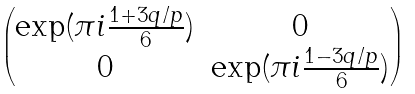Convert formula to latex. <formula><loc_0><loc_0><loc_500><loc_500>\begin{pmatrix} \exp ( \pi i \frac { 1 + 3 q / p } { 6 } ) & 0 \\ 0 & \exp ( \pi i \frac { 1 - 3 q / p } { 6 } ) \end{pmatrix}</formula> 